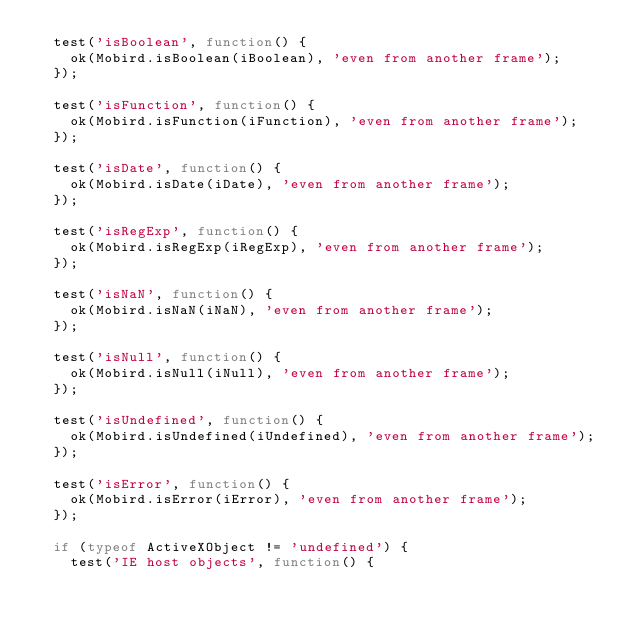<code> <loc_0><loc_0><loc_500><loc_500><_JavaScript_>  test('isBoolean', function() {
    ok(Mobird.isBoolean(iBoolean), 'even from another frame');
  });

  test('isFunction', function() {
    ok(Mobird.isFunction(iFunction), 'even from another frame');
  });

  test('isDate', function() {
    ok(Mobird.isDate(iDate), 'even from another frame');
  });

  test('isRegExp', function() {
    ok(Mobird.isRegExp(iRegExp), 'even from another frame');
  });

  test('isNaN', function() {
    ok(Mobird.isNaN(iNaN), 'even from another frame');
  });

  test('isNull', function() {
    ok(Mobird.isNull(iNull), 'even from another frame');
  });

  test('isUndefined', function() {
    ok(Mobird.isUndefined(iUndefined), 'even from another frame');
  });

  test('isError', function() {
    ok(Mobird.isError(iError), 'even from another frame');
  });

  if (typeof ActiveXObject != 'undefined') {
    test('IE host objects', function() {</code> 